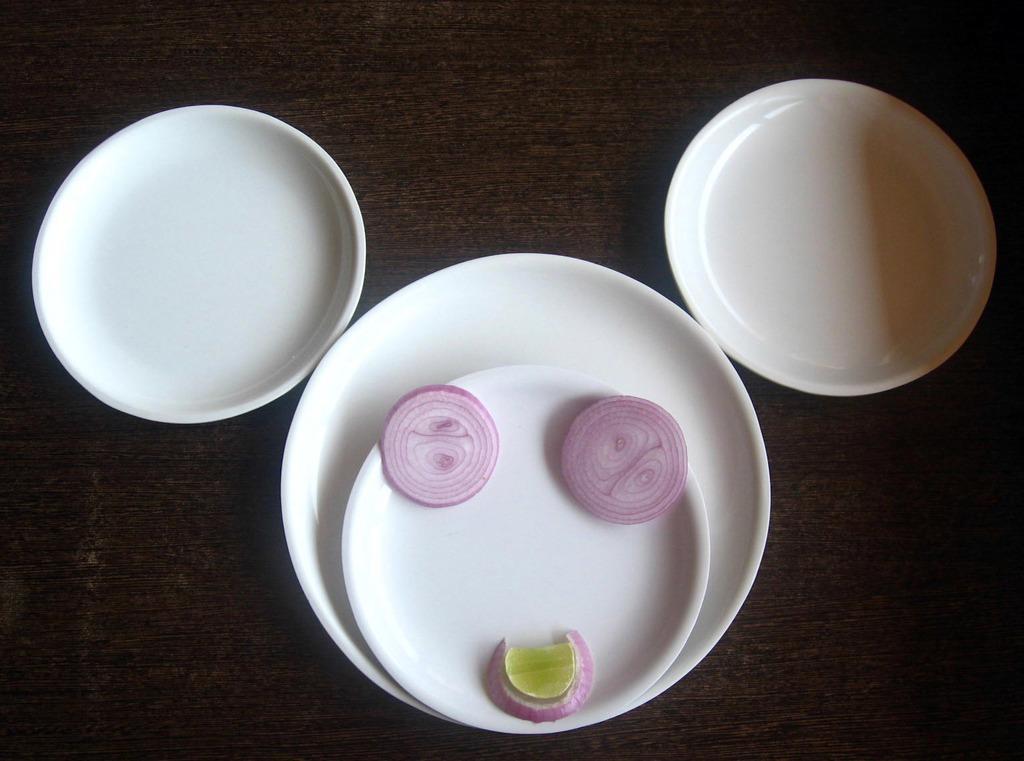Can you describe this image briefly? In this picture, we see four plates. In one of the plates, we see chopped onions and a lemon. These plates are placed on the brown table. 